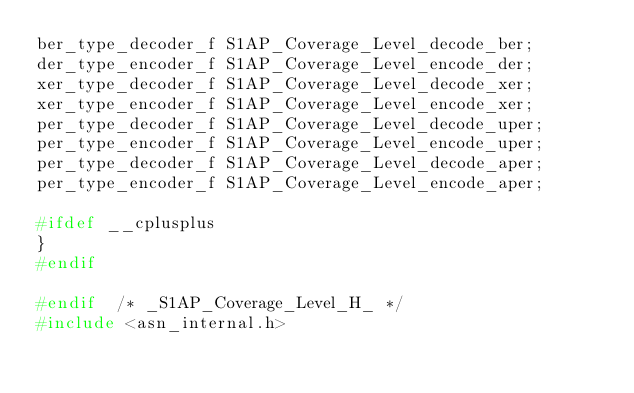<code> <loc_0><loc_0><loc_500><loc_500><_C_>ber_type_decoder_f S1AP_Coverage_Level_decode_ber;
der_type_encoder_f S1AP_Coverage_Level_encode_der;
xer_type_decoder_f S1AP_Coverage_Level_decode_xer;
xer_type_encoder_f S1AP_Coverage_Level_encode_xer;
per_type_decoder_f S1AP_Coverage_Level_decode_uper;
per_type_encoder_f S1AP_Coverage_Level_encode_uper;
per_type_decoder_f S1AP_Coverage_Level_decode_aper;
per_type_encoder_f S1AP_Coverage_Level_encode_aper;

#ifdef __cplusplus
}
#endif

#endif	/* _S1AP_Coverage_Level_H_ */
#include <asn_internal.h>
</code> 